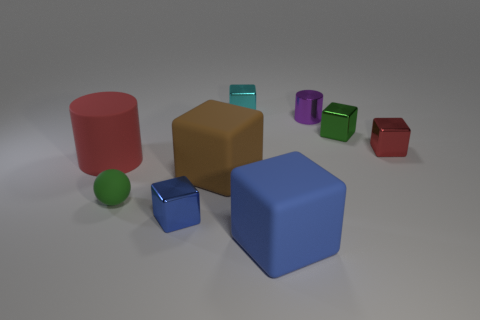Subtract all red blocks. How many blocks are left? 5 Subtract all cyan metallic blocks. How many blocks are left? 5 Subtract all gray blocks. Subtract all blue cylinders. How many blocks are left? 6 Subtract all balls. How many objects are left? 8 Subtract all red objects. Subtract all green matte cylinders. How many objects are left? 7 Add 1 small metal cylinders. How many small metal cylinders are left? 2 Add 9 big green rubber cylinders. How many big green rubber cylinders exist? 9 Subtract 1 cyan blocks. How many objects are left? 8 